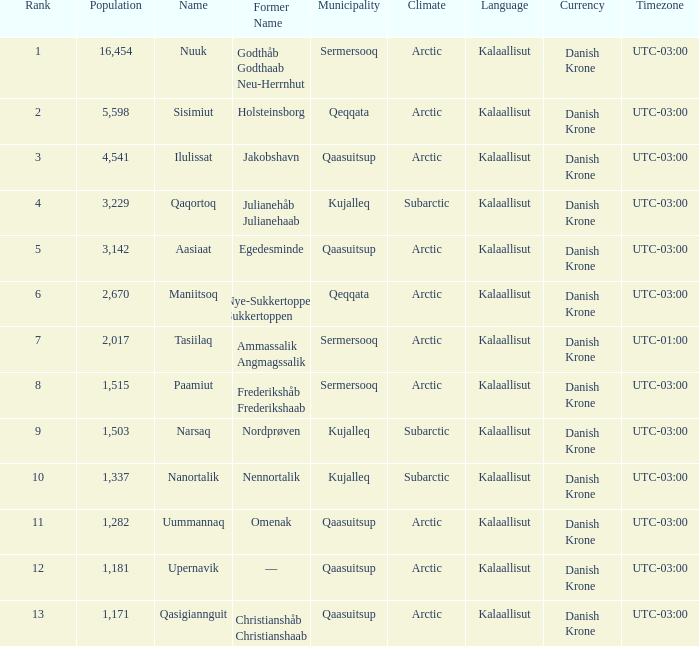What is the population for Rank 11? 1282.0. 